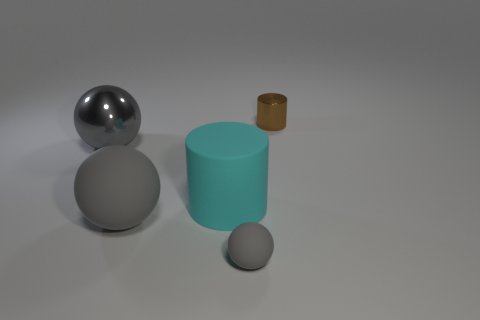How many shiny objects have the same size as the gray metallic sphere?
Your answer should be compact. 0. Is there a small brown metal object behind the cylinder that is behind the cyan matte thing?
Provide a succinct answer. No. What number of things are big shiny things or cyan shiny spheres?
Give a very brief answer. 1. There is a rubber object behind the big gray matte object right of the big gray sphere behind the big gray matte ball; what color is it?
Provide a succinct answer. Cyan. Is there anything else that is the same color as the large shiny sphere?
Ensure brevity in your answer.  Yes. Is the size of the gray shiny object the same as the brown metal cylinder?
Offer a very short reply. No. How many objects are big objects that are to the left of the large rubber ball or gray spheres that are on the right side of the big gray rubber sphere?
Your answer should be very brief. 2. What material is the ball in front of the large gray object in front of the metal ball?
Provide a short and direct response. Rubber. How many other objects are there of the same material as the tiny sphere?
Ensure brevity in your answer.  2. Do the small brown metallic object and the cyan matte object have the same shape?
Provide a short and direct response. Yes. 